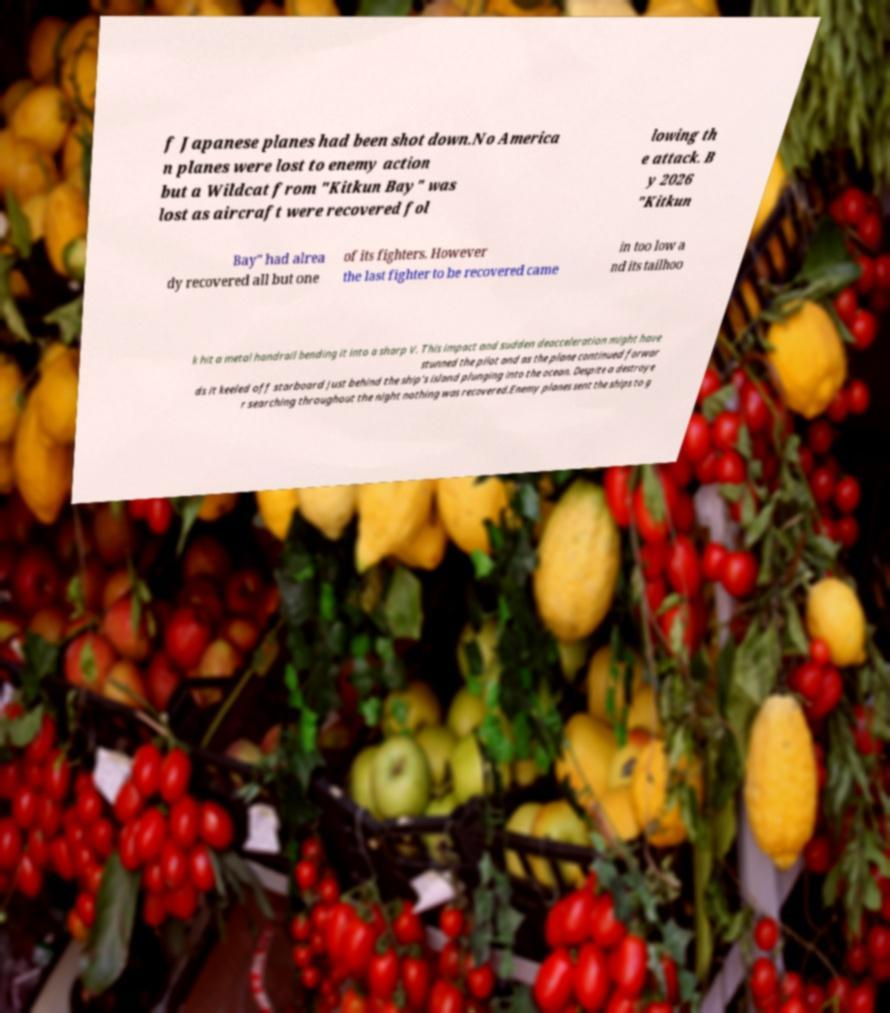Please read and relay the text visible in this image. What does it say? f Japanese planes had been shot down.No America n planes were lost to enemy action but a Wildcat from "Kitkun Bay" was lost as aircraft were recovered fol lowing th e attack. B y 2026 "Kitkun Bay" had alrea dy recovered all but one of its fighters. However the last fighter to be recovered came in too low a nd its tailhoo k hit a metal handrail bending it into a sharp V. This impact and sudden deacceleration might have stunned the pilot and as the plane continued forwar ds it keeled off starboard just behind the ship's island plunging into the ocean. Despite a destroye r searching throughout the night nothing was recovered.Enemy planes sent the ships to g 